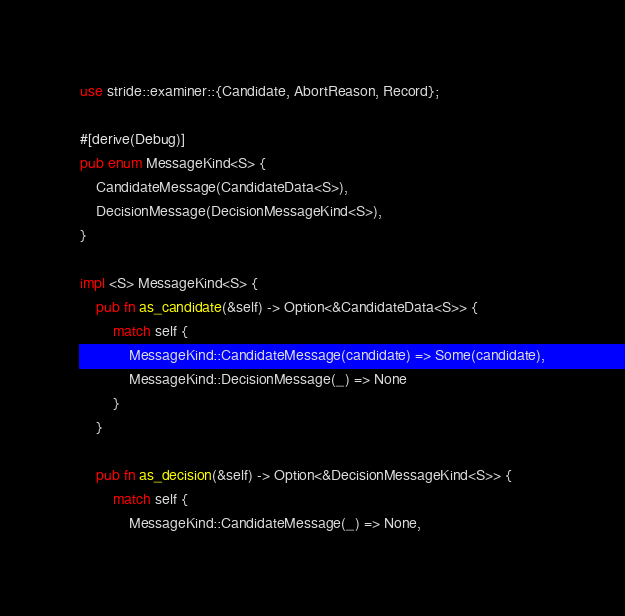Convert code to text. <code><loc_0><loc_0><loc_500><loc_500><_Rust_>use stride::examiner::{Candidate, AbortReason, Record};

#[derive(Debug)]
pub enum MessageKind<S> {
    CandidateMessage(CandidateData<S>),
    DecisionMessage(DecisionMessageKind<S>),
}

impl <S> MessageKind<S> {
    pub fn as_candidate(&self) -> Option<&CandidateData<S>> {
        match self {
            MessageKind::CandidateMessage(candidate) => Some(candidate),
            MessageKind::DecisionMessage(_) => None
        }
    }

    pub fn as_decision(&self) -> Option<&DecisionMessageKind<S>> {
        match self {
            MessageKind::CandidateMessage(_) => None,</code> 